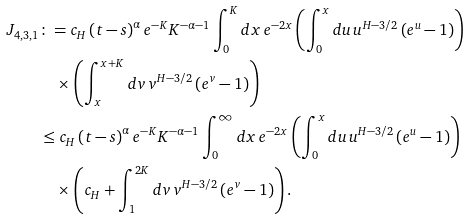<formula> <loc_0><loc_0><loc_500><loc_500>J _ { 4 , 3 , 1 } & \colon = c _ { H } \left ( t - s \right ) ^ { \alpha } e ^ { - K } K ^ { - \alpha - 1 } \int _ { 0 } ^ { K } d x \, e ^ { - 2 x } \left ( \int _ { 0 } ^ { x } d u \, u ^ { H - 3 / 2 } \left ( e ^ { u } - 1 \right ) \right ) \\ & \quad \times \left ( \int _ { x } ^ { x + K } d v \, v ^ { H - 3 / 2 } \left ( e ^ { v } - 1 \right ) \right ) \\ & \leq c _ { H } \left ( t - s \right ) ^ { \alpha } e ^ { - K } K ^ { - \alpha - 1 } \int _ { 0 } ^ { \infty } d x \, e ^ { - 2 x } \left ( \int _ { 0 } ^ { x } d u \, u ^ { H - 3 / 2 } \left ( e ^ { u } - 1 \right ) \right ) \\ & \quad \times \left ( c _ { H } + \int _ { 1 } ^ { 2 K } d v \, v ^ { H - 3 / 2 } \left ( e ^ { v } - 1 \right ) \right ) .</formula> 